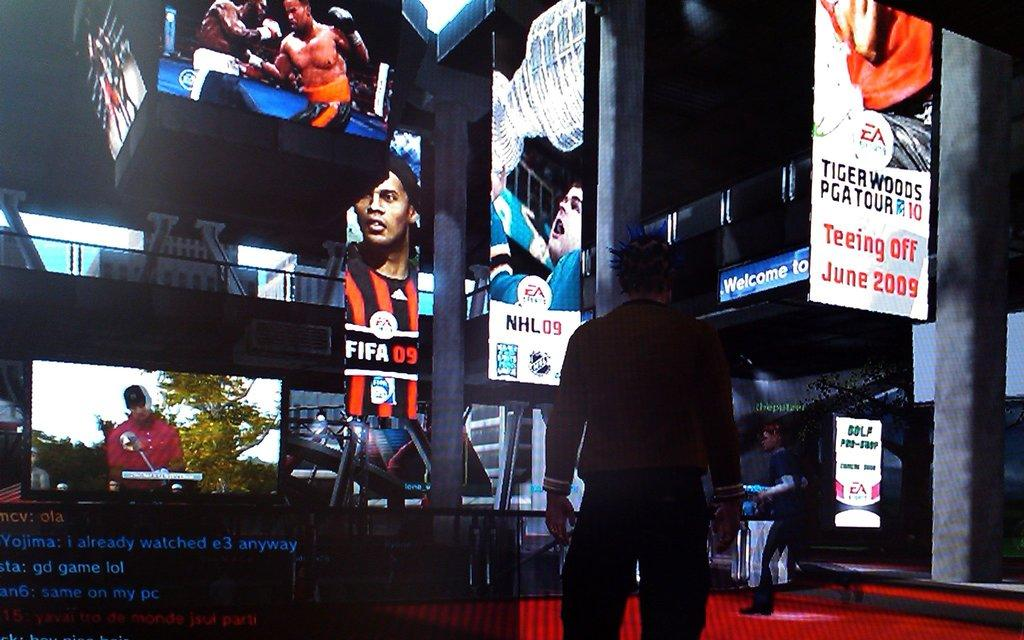What type of image is being described? The image is animated. Can you describe the main subject in the image? There is a person standing in the middle of the image. What objects are in front of the person? Digital screens are present in front of the person. Can you see a pig in the image? There is no pig present in the image. 